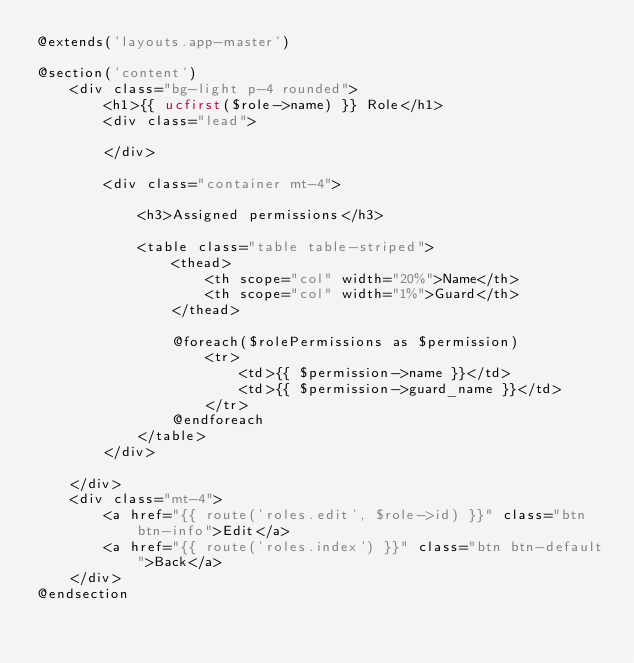Convert code to text. <code><loc_0><loc_0><loc_500><loc_500><_PHP_>@extends('layouts.app-master')

@section('content')
    <div class="bg-light p-4 rounded">
        <h1>{{ ucfirst($role->name) }} Role</h1>
        <div class="lead">

        </div>

        <div class="container mt-4">

            <h3>Assigned permissions</h3>

            <table class="table table-striped">
                <thead>
                    <th scope="col" width="20%">Name</th>
                    <th scope="col" width="1%">Guard</th>
                </thead>

                @foreach($rolePermissions as $permission)
                    <tr>
                        <td>{{ $permission->name }}</td>
                        <td>{{ $permission->guard_name }}</td>
                    </tr>
                @endforeach
            </table>
        </div>

    </div>
    <div class="mt-4">
        <a href="{{ route('roles.edit', $role->id) }}" class="btn btn-info">Edit</a>
        <a href="{{ route('roles.index') }}" class="btn btn-default">Back</a>
    </div>
@endsection
</code> 